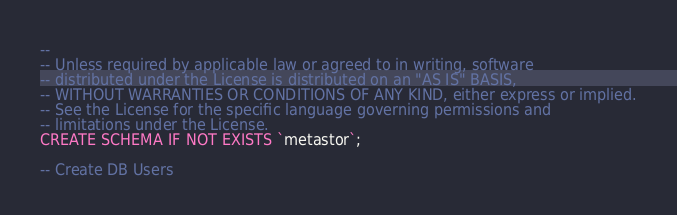<code> <loc_0><loc_0><loc_500><loc_500><_SQL_>--
-- Unless required by applicable law or agreed to in writing, software
-- distributed under the License is distributed on an "AS IS" BASIS,
-- WITHOUT WARRANTIES OR CONDITIONS OF ANY KIND, either express or implied.
-- See the License for the specific language governing permissions and
-- limitations under the License.
CREATE SCHEMA IF NOT EXISTS `metastor`;

-- Create DB Users</code> 